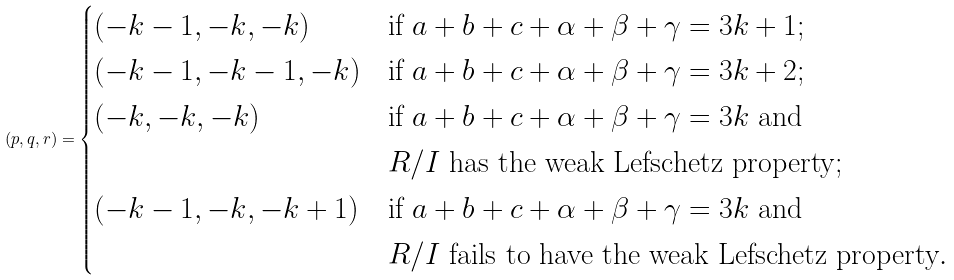<formula> <loc_0><loc_0><loc_500><loc_500>( p , q , r ) = \begin{cases} ( - k - 1 , - k , - k ) & \text {if } a + b + c + \alpha + \beta + \gamma = 3 k + 1 ; \\ ( - k - 1 , - k - 1 , - k ) & \text {if } a + b + c + \alpha + \beta + \gamma = 3 k + 2 ; \\ ( - k , - k , - k ) & \text {if } a + b + c + \alpha + \beta + \gamma = 3 k \text { and} \\ & \text {$R/I$ has the weak Lefschetz property} ; \\ ( - k - 1 , - k , - k + 1 ) & \text {if } a + b + c + \alpha + \beta + \gamma = 3 k \text { and} \\ & \text {$R/I$ fails to have the weak Lefschetz property} . \end{cases}</formula> 